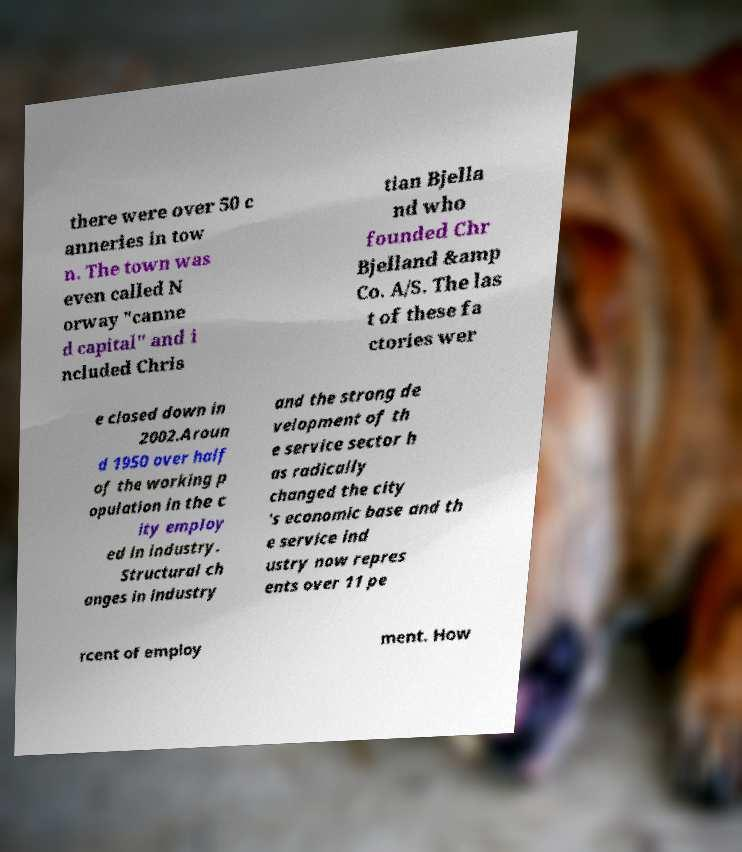Could you extract and type out the text from this image? there were over 50 c anneries in tow n. The town was even called N orway "canne d capital" and i ncluded Chris tian Bjella nd who founded Chr Bjelland &amp Co. A/S. The las t of these fa ctories wer e closed down in 2002.Aroun d 1950 over half of the working p opulation in the c ity employ ed in industry. Structural ch anges in industry and the strong de velopment of th e service sector h as radically changed the city 's economic base and th e service ind ustry now repres ents over 11 pe rcent of employ ment. How 